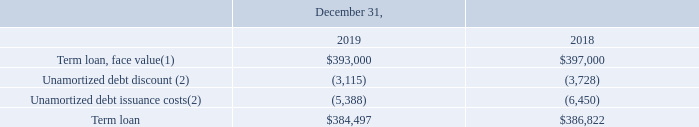GreenSky, Inc. NOTES TO CONSOLIDATED FINANCIAL STATEMENTS — (Continued) (United States Dollars in thousands, except per share data, unless otherwise stated)
Key details of the term loan are as follows:
(1) The principal balance of the term loan is scheduled to be repaid on a quarterly basis at an amortization rate of 0.25% per quarter through December 31, 2024, with the balance due at maturity. For each of the next five years, principal repayments on the term loan are expected to be $4,000.
(2) For the years ended December 31, 2019 and 2018, debt discount of $613 and $593, respectively, and debt issuance costs of $1,062
and $1,091, respectively, were amortized into interest expense in the Consolidated Statements of Operations. Giving effect to the
amortization of debt discount and debt issuance costs on the term loan, the effective interest rates were 5.95% and 5.99% during the
years ended December 31, 2019 and 2018, respectively.
How is the principal balance of the term loan scheduled to be repaid? On a quarterly basis at an amortization rate of 0.25% per quarter through december 31, 2024, with the balance due at maturity. What was the unamortized debt discount in 2018?
Answer scale should be: thousand. (3,728). Which years does the table provide information for Key details of the term loan? 2019, 2018. How many years did the face value of term loan exceed $300,000 thousand? 2019##2018
Answer: 2. What was the change in the Unamortized debt discount between 2018 and 2019?
Answer scale should be: thousand. -3,115-(-3,728)
Answer: 613. What was the percentage change in the term loan between 2018 and 2019?
Answer scale should be: percent. (384,497-386,822)/386,822
Answer: -0.6. 